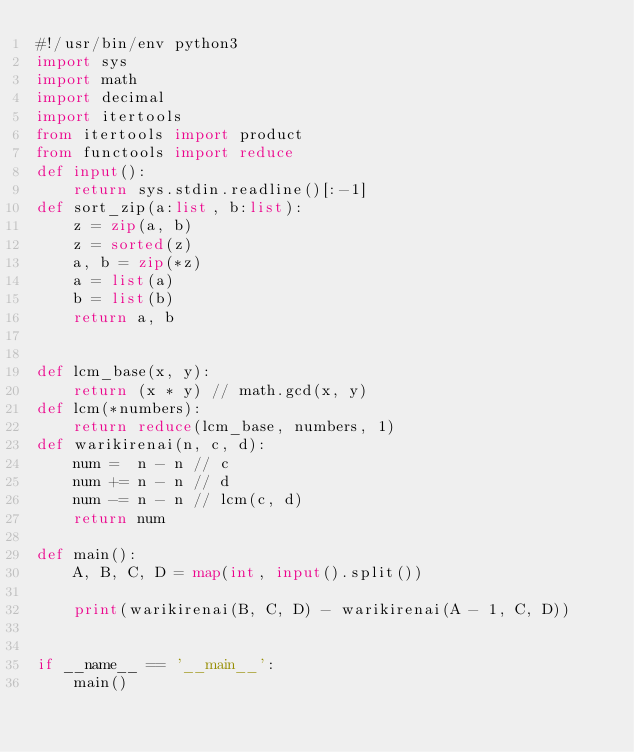<code> <loc_0><loc_0><loc_500><loc_500><_Python_>#!/usr/bin/env python3
import sys
import math
import decimal
import itertools
from itertools import product
from functools import reduce
def input():
    return sys.stdin.readline()[:-1]
def sort_zip(a:list, b:list):
    z = zip(a, b)
    z = sorted(z)
    a, b = zip(*z)
    a = list(a)
    b = list(b)
    return a, b


def lcm_base(x, y):
    return (x * y) // math.gcd(x, y)
def lcm(*numbers):
    return reduce(lcm_base, numbers, 1)
def warikirenai(n, c, d):
    num =  n - n // c
    num += n - n // d
    num -= n - n // lcm(c, d)
    return num

def main():
    A, B, C, D = map(int, input().split())

    print(warikirenai(B, C, D) - warikirenai(A - 1, C, D))


if __name__ == '__main__':
    main()
</code> 